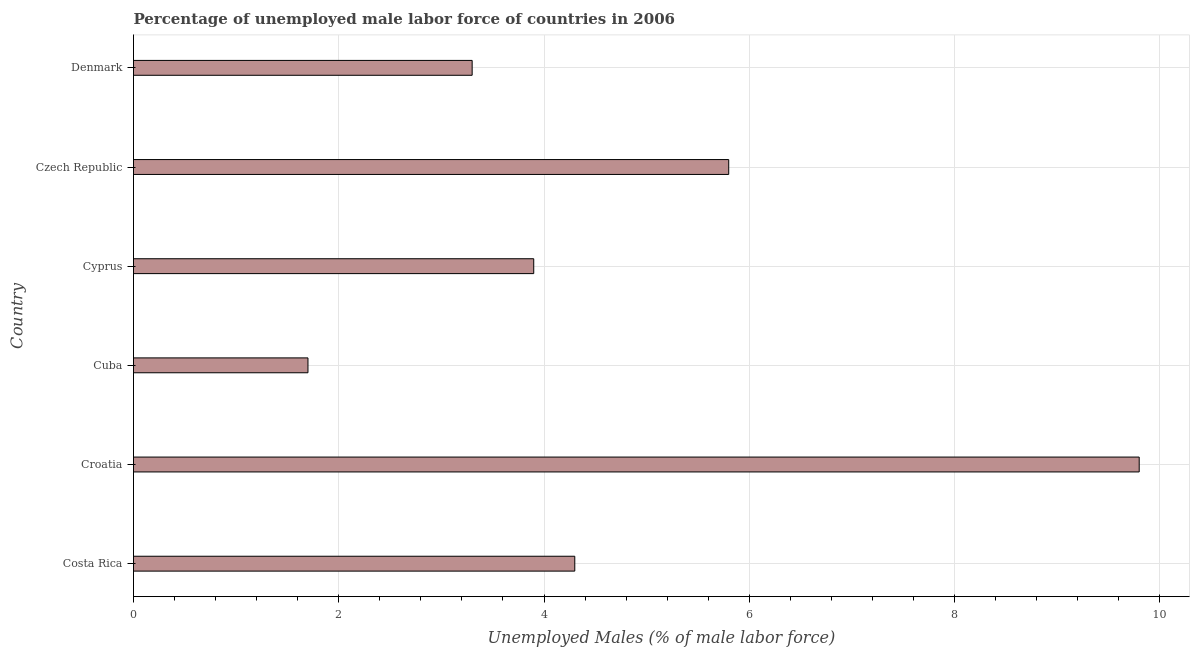Does the graph contain any zero values?
Give a very brief answer. No. What is the title of the graph?
Your answer should be very brief. Percentage of unemployed male labor force of countries in 2006. What is the label or title of the X-axis?
Offer a very short reply. Unemployed Males (% of male labor force). What is the label or title of the Y-axis?
Your answer should be compact. Country. What is the total unemployed male labour force in Croatia?
Your response must be concise. 9.8. Across all countries, what is the maximum total unemployed male labour force?
Ensure brevity in your answer.  9.8. Across all countries, what is the minimum total unemployed male labour force?
Your response must be concise. 1.7. In which country was the total unemployed male labour force maximum?
Your response must be concise. Croatia. In which country was the total unemployed male labour force minimum?
Provide a succinct answer. Cuba. What is the sum of the total unemployed male labour force?
Offer a terse response. 28.8. What is the difference between the total unemployed male labour force in Croatia and Cuba?
Ensure brevity in your answer.  8.1. What is the average total unemployed male labour force per country?
Provide a succinct answer. 4.8. What is the median total unemployed male labour force?
Give a very brief answer. 4.1. In how many countries, is the total unemployed male labour force greater than 5.6 %?
Give a very brief answer. 2. What is the ratio of the total unemployed male labour force in Costa Rica to that in Cyprus?
Provide a succinct answer. 1.1. Is the total unemployed male labour force in Cyprus less than that in Czech Republic?
Offer a terse response. Yes. Is the difference between the total unemployed male labour force in Cuba and Cyprus greater than the difference between any two countries?
Your answer should be very brief. No. What is the difference between the highest and the second highest total unemployed male labour force?
Your answer should be very brief. 4. What is the difference between the highest and the lowest total unemployed male labour force?
Your answer should be very brief. 8.1. How many bars are there?
Ensure brevity in your answer.  6. What is the difference between two consecutive major ticks on the X-axis?
Ensure brevity in your answer.  2. Are the values on the major ticks of X-axis written in scientific E-notation?
Give a very brief answer. No. What is the Unemployed Males (% of male labor force) in Costa Rica?
Ensure brevity in your answer.  4.3. What is the Unemployed Males (% of male labor force) in Croatia?
Provide a short and direct response. 9.8. What is the Unemployed Males (% of male labor force) in Cuba?
Your answer should be very brief. 1.7. What is the Unemployed Males (% of male labor force) of Cyprus?
Make the answer very short. 3.9. What is the Unemployed Males (% of male labor force) of Czech Republic?
Your answer should be very brief. 5.8. What is the Unemployed Males (% of male labor force) of Denmark?
Make the answer very short. 3.3. What is the difference between the Unemployed Males (% of male labor force) in Costa Rica and Croatia?
Your response must be concise. -5.5. What is the difference between the Unemployed Males (% of male labor force) in Costa Rica and Cuba?
Provide a succinct answer. 2.6. What is the difference between the Unemployed Males (% of male labor force) in Costa Rica and Czech Republic?
Provide a succinct answer. -1.5. What is the difference between the Unemployed Males (% of male labor force) in Croatia and Cuba?
Offer a terse response. 8.1. What is the difference between the Unemployed Males (% of male labor force) in Cuba and Cyprus?
Provide a succinct answer. -2.2. What is the difference between the Unemployed Males (% of male labor force) in Cuba and Czech Republic?
Provide a short and direct response. -4.1. What is the difference between the Unemployed Males (% of male labor force) in Cuba and Denmark?
Make the answer very short. -1.6. What is the difference between the Unemployed Males (% of male labor force) in Czech Republic and Denmark?
Give a very brief answer. 2.5. What is the ratio of the Unemployed Males (% of male labor force) in Costa Rica to that in Croatia?
Your answer should be very brief. 0.44. What is the ratio of the Unemployed Males (% of male labor force) in Costa Rica to that in Cuba?
Keep it short and to the point. 2.53. What is the ratio of the Unemployed Males (% of male labor force) in Costa Rica to that in Cyprus?
Provide a short and direct response. 1.1. What is the ratio of the Unemployed Males (% of male labor force) in Costa Rica to that in Czech Republic?
Your response must be concise. 0.74. What is the ratio of the Unemployed Males (% of male labor force) in Costa Rica to that in Denmark?
Provide a succinct answer. 1.3. What is the ratio of the Unemployed Males (% of male labor force) in Croatia to that in Cuba?
Your answer should be very brief. 5.76. What is the ratio of the Unemployed Males (% of male labor force) in Croatia to that in Cyprus?
Offer a very short reply. 2.51. What is the ratio of the Unemployed Males (% of male labor force) in Croatia to that in Czech Republic?
Keep it short and to the point. 1.69. What is the ratio of the Unemployed Males (% of male labor force) in Croatia to that in Denmark?
Make the answer very short. 2.97. What is the ratio of the Unemployed Males (% of male labor force) in Cuba to that in Cyprus?
Provide a succinct answer. 0.44. What is the ratio of the Unemployed Males (% of male labor force) in Cuba to that in Czech Republic?
Provide a succinct answer. 0.29. What is the ratio of the Unemployed Males (% of male labor force) in Cuba to that in Denmark?
Give a very brief answer. 0.52. What is the ratio of the Unemployed Males (% of male labor force) in Cyprus to that in Czech Republic?
Make the answer very short. 0.67. What is the ratio of the Unemployed Males (% of male labor force) in Cyprus to that in Denmark?
Your response must be concise. 1.18. What is the ratio of the Unemployed Males (% of male labor force) in Czech Republic to that in Denmark?
Your answer should be compact. 1.76. 